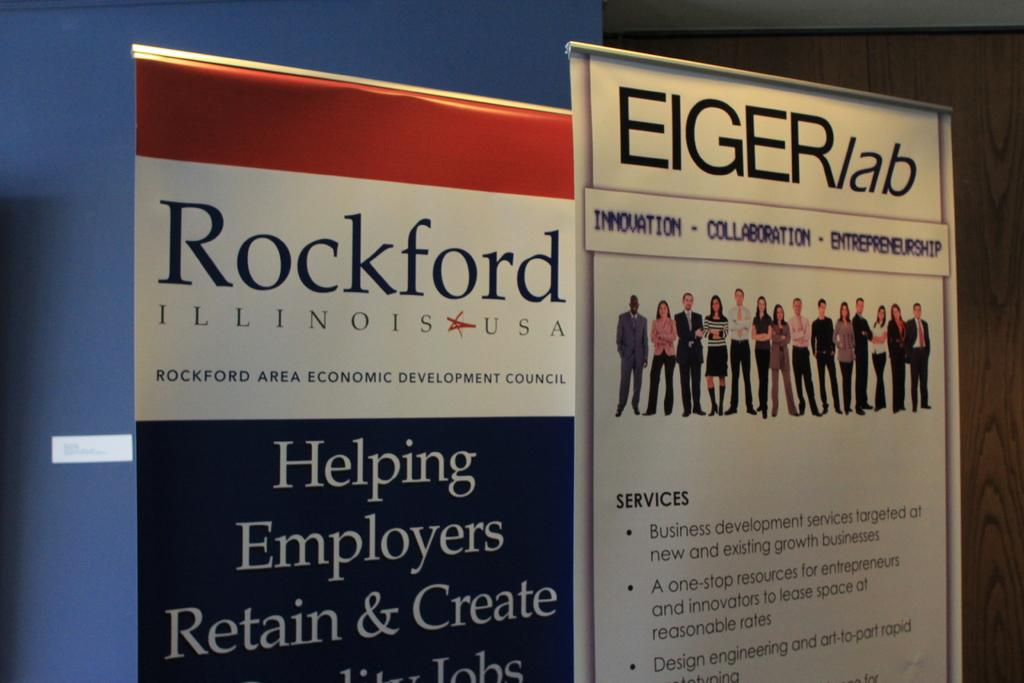<image>
Write a terse but informative summary of the picture. A Rockford Illinois economic development council poster sign. 